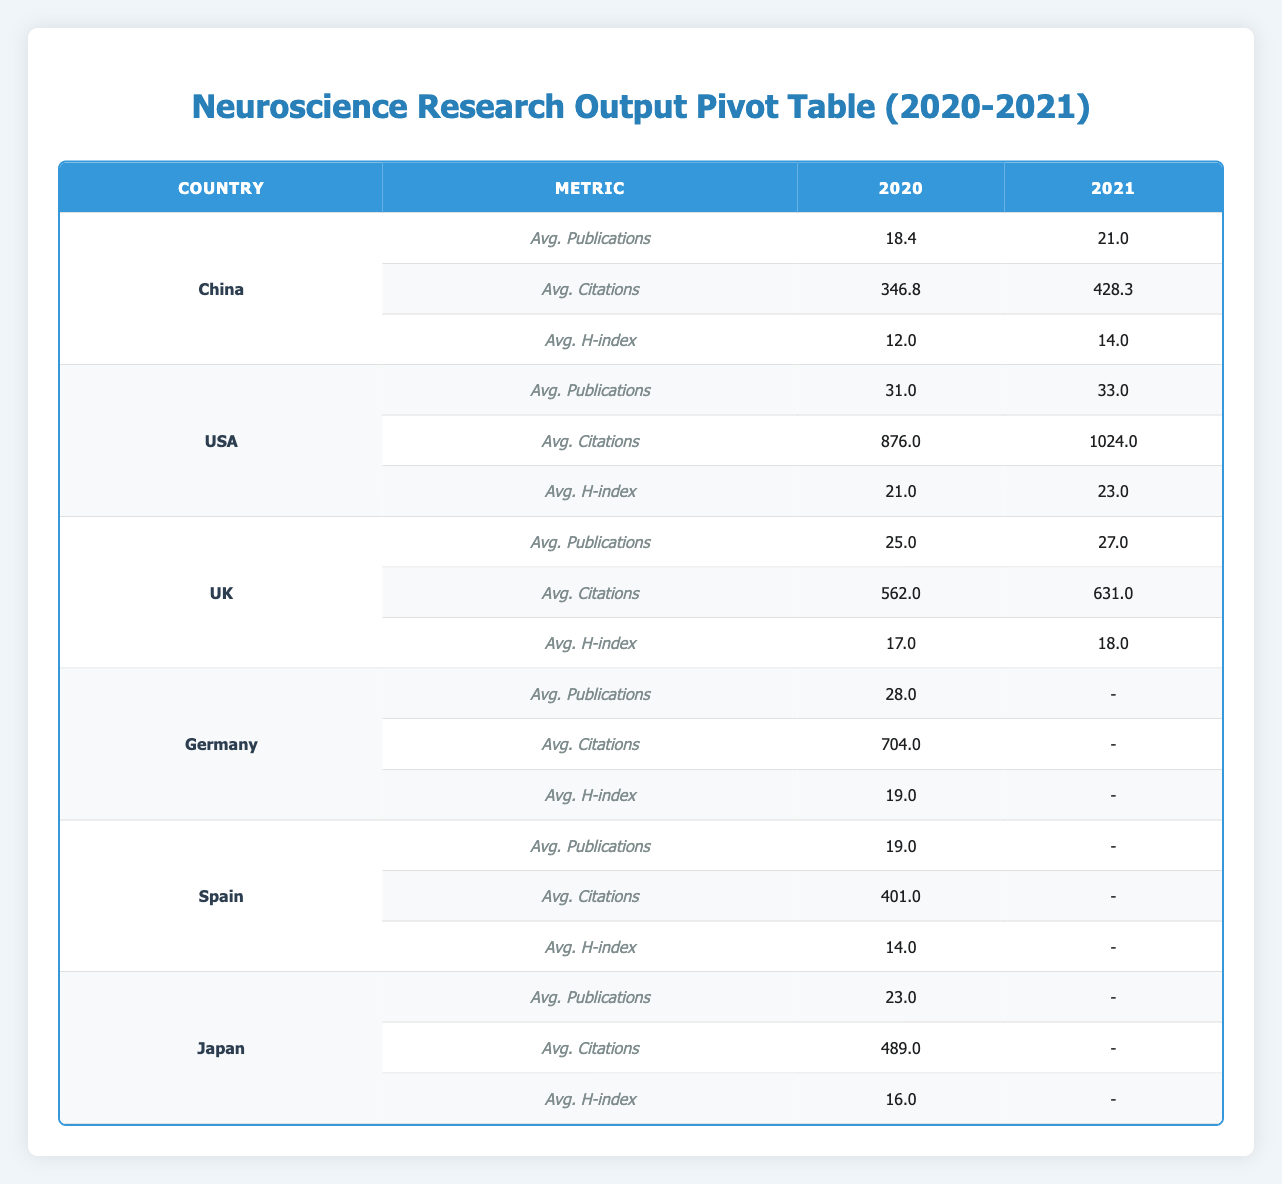What is the average number of publications for researchers in China in 2020? For China in 2020, the publications are 18, 22, 15, 20, and 17. To find the average, we sum these: (18 + 22 + 15 + 20 + 17) = 92. There are 5 researchers, so the average is 92/5 = 18.4.
Answer: 18.4 How many citations did researchers from the USA have in 2021? For the USA in 2021, John Smith had 1024 citations. Therefore, the total number of citations for the USA in this year is 1024.
Answer: 1024 Did Germany have any researchers with data in 2021? The data table shows no entries for Germany in 2021. Therefore, there were no researchers from Germany with available data for that year.
Answer: No What is the difference in average citations between researchers in China and the UK in 2021? In 2021, the average citations for China are 428.3 and for the UK are 631. The difference is calculated as 631 - 428.3 = 202.7.
Answer: 202.7 Which country had the highest average H-index in 2020? The average H-index for China was 12.0, for the USA it was 21.0, for the UK it was 17.0, for Germany it was 19.0, and for Japan, it was 16.0. The highest average is 21.0 from the USA.
Answer: USA What was the average number of publications for all countries in 2020? We sum the publications for all countries: (18 + 22 + 31 + 25 + 15 + 28 + 20 + 19 + 17 + 23) =  218. There are 10 researchers in total, so the average is 218/10 = 21.8.
Answer: 21.8 Did any country have more than 30 publications on average in 2021? In 2021, the average number of publications for China was 21.0, for the USA was 33.0, for the UK was 27.0, and for others like Germany, Spain, and Japan, we have no data for that year. Since the USA's average is 33.0, it exceeds the threshold.
Answer: Yes What is the H-index for the Chinese researcher with the most publications in 2020? The researchers from China in 2020 had publications of 18, 22, 15, 20, and 17. Zhang Mei had the most with 22 publications and had an H-index of 14.
Answer: 14 What was the percentage increase in average publications for researchers in China from 2020 to 2021? The average publications for 2020 in China was 18.4, and for 2021 it was 21.0. The increase is 21.0 - 18.4 = 2.6. The percentage increase is (2.6 / 18.4) * 100, which is approximately 14.13%.
Answer: 14.13% 